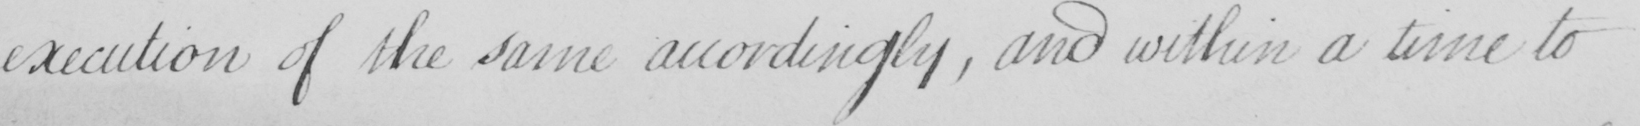Please provide the text content of this handwritten line. execution of the same accordingly , and within a time to 